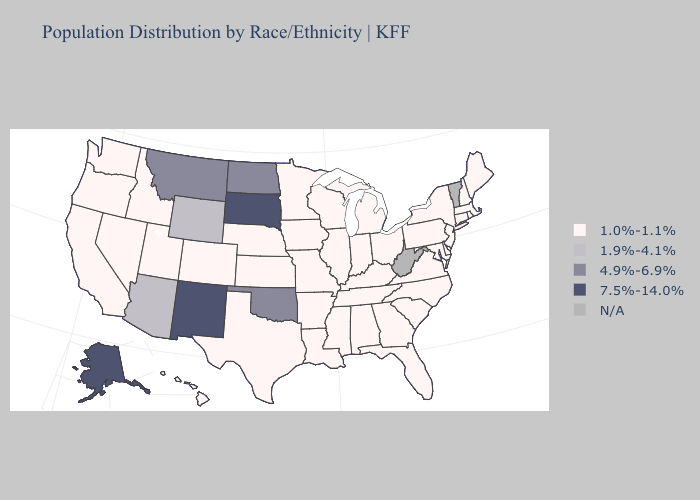Does North Dakota have the lowest value in the USA?
Short answer required. No. Name the states that have a value in the range 4.9%-6.9%?
Keep it brief. Montana, North Dakota, Oklahoma. What is the value of West Virginia?
Keep it brief. N/A. What is the value of South Dakota?
Concise answer only. 7.5%-14.0%. Does Michigan have the highest value in the USA?
Write a very short answer. No. What is the value of South Carolina?
Concise answer only. 1.0%-1.1%. Does the map have missing data?
Concise answer only. Yes. Does Arkansas have the lowest value in the South?
Write a very short answer. Yes. What is the highest value in states that border Oregon?
Concise answer only. 1.0%-1.1%. Does New Mexico have the highest value in the USA?
Answer briefly. Yes. How many symbols are there in the legend?
Answer briefly. 5. Is the legend a continuous bar?
Keep it brief. No. What is the value of Kentucky?
Concise answer only. 1.0%-1.1%. Name the states that have a value in the range 1.0%-1.1%?
Give a very brief answer. Alabama, Arkansas, California, Colorado, Connecticut, Delaware, Florida, Georgia, Hawaii, Idaho, Illinois, Indiana, Iowa, Kansas, Kentucky, Louisiana, Maine, Maryland, Massachusetts, Michigan, Minnesota, Mississippi, Missouri, Nebraska, Nevada, New Hampshire, New Jersey, New York, North Carolina, Ohio, Oregon, Pennsylvania, Rhode Island, South Carolina, Tennessee, Texas, Utah, Virginia, Washington, Wisconsin. 